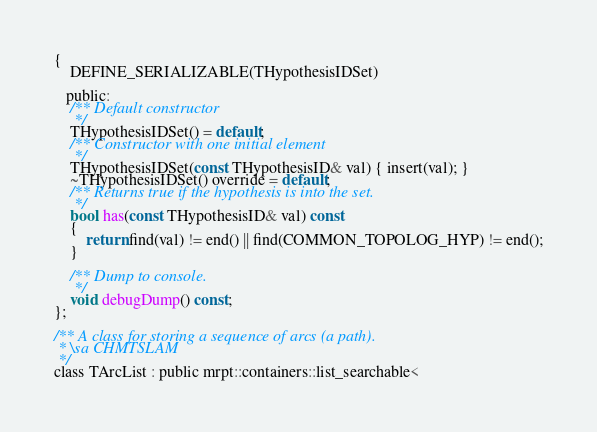Convert code to text. <code><loc_0><loc_0><loc_500><loc_500><_C_>{
	DEFINE_SERIALIZABLE(THypothesisIDSet)

   public:
	/** Default constructor
	 */
	THypothesisIDSet() = default;
	/** Constructor with one initial element
	 */
	THypothesisIDSet(const THypothesisID& val) { insert(val); }
	~THypothesisIDSet() override = default;
	/** Returns true if the hypothesis is into the set.
	 */
	bool has(const THypothesisID& val) const
	{
		return find(val) != end() || find(COMMON_TOPOLOG_HYP) != end();
	}

	/** Dump to console.
	 */
	void debugDump() const;
};

/** A class for storing a sequence of arcs (a path).
 * \sa CHMTSLAM
 */
class TArcList : public mrpt::containers::list_searchable<</code> 